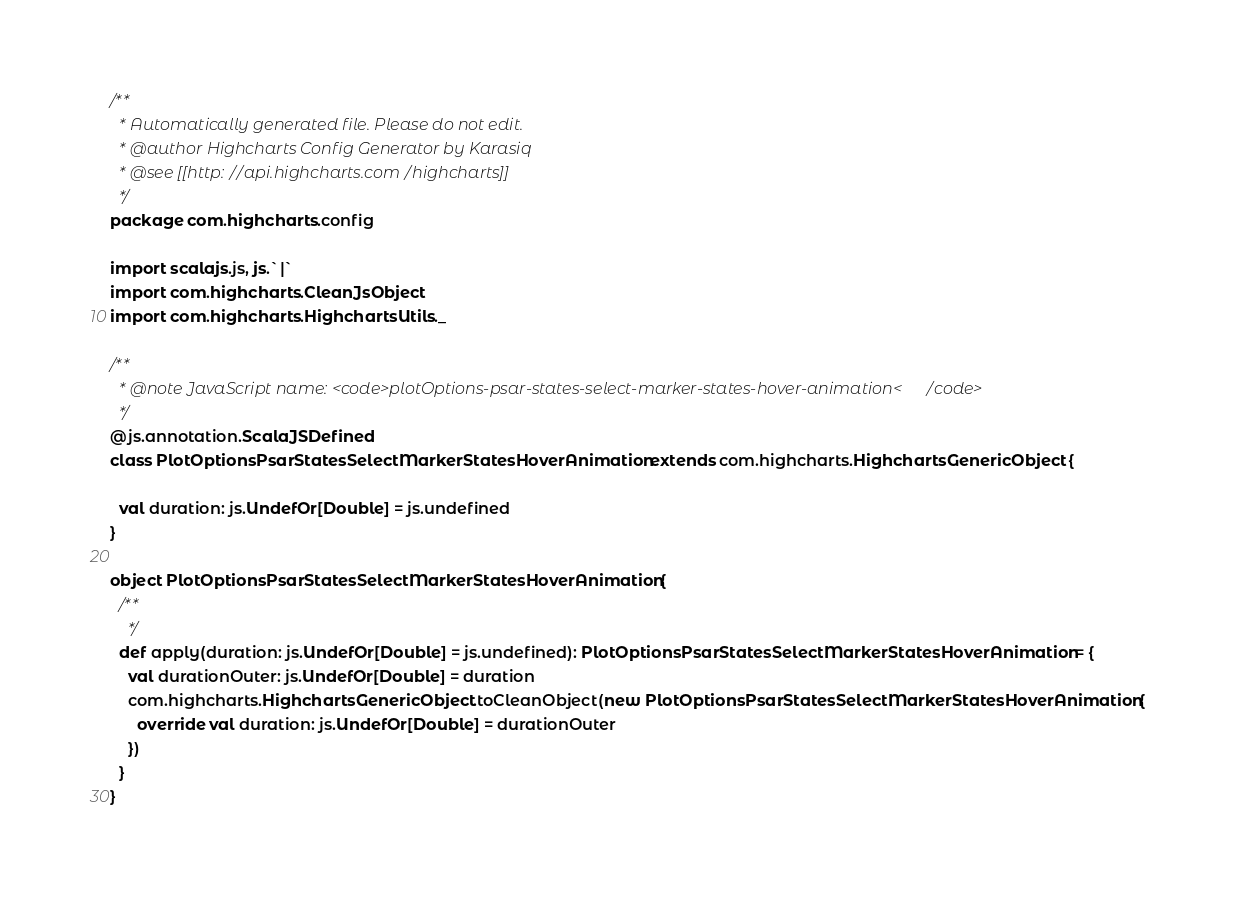Convert code to text. <code><loc_0><loc_0><loc_500><loc_500><_Scala_>/**
  * Automatically generated file. Please do not edit.
  * @author Highcharts Config Generator by Karasiq
  * @see [[http://api.highcharts.com/highcharts]]
  */
package com.highcharts.config

import scalajs.js, js.`|`
import com.highcharts.CleanJsObject
import com.highcharts.HighchartsUtils._

/**
  * @note JavaScript name: <code>plotOptions-psar-states-select-marker-states-hover-animation</code>
  */
@js.annotation.ScalaJSDefined
class PlotOptionsPsarStatesSelectMarkerStatesHoverAnimation extends com.highcharts.HighchartsGenericObject {

  val duration: js.UndefOr[Double] = js.undefined
}

object PlotOptionsPsarStatesSelectMarkerStatesHoverAnimation {
  /**
    */
  def apply(duration: js.UndefOr[Double] = js.undefined): PlotOptionsPsarStatesSelectMarkerStatesHoverAnimation = {
    val durationOuter: js.UndefOr[Double] = duration
    com.highcharts.HighchartsGenericObject.toCleanObject(new PlotOptionsPsarStatesSelectMarkerStatesHoverAnimation {
      override val duration: js.UndefOr[Double] = durationOuter
    })
  }
}
</code> 